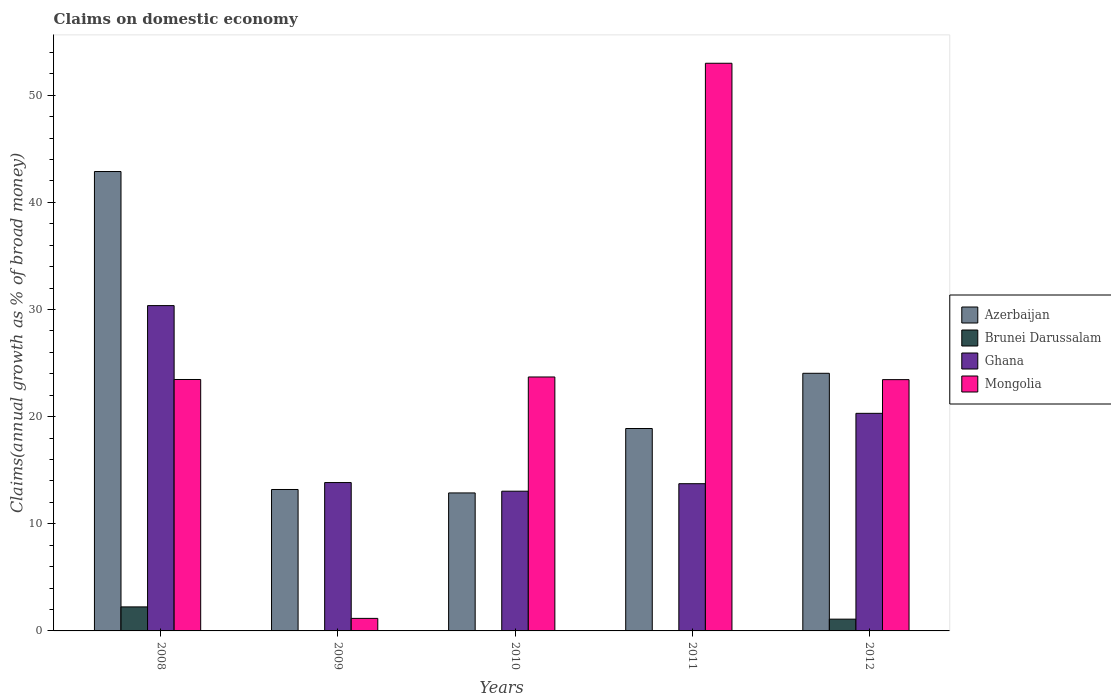How many different coloured bars are there?
Provide a succinct answer. 4. How many bars are there on the 5th tick from the left?
Your response must be concise. 4. What is the percentage of broad money claimed on domestic economy in Azerbaijan in 2008?
Your answer should be very brief. 42.88. Across all years, what is the maximum percentage of broad money claimed on domestic economy in Mongolia?
Your answer should be very brief. 52.99. Across all years, what is the minimum percentage of broad money claimed on domestic economy in Azerbaijan?
Offer a terse response. 12.88. In which year was the percentage of broad money claimed on domestic economy in Ghana maximum?
Offer a very short reply. 2008. What is the total percentage of broad money claimed on domestic economy in Mongolia in the graph?
Keep it short and to the point. 124.78. What is the difference between the percentage of broad money claimed on domestic economy in Mongolia in 2011 and that in 2012?
Give a very brief answer. 29.53. What is the difference between the percentage of broad money claimed on domestic economy in Ghana in 2011 and the percentage of broad money claimed on domestic economy in Azerbaijan in 2010?
Offer a very short reply. 0.86. What is the average percentage of broad money claimed on domestic economy in Brunei Darussalam per year?
Your answer should be very brief. 0.67. In the year 2012, what is the difference between the percentage of broad money claimed on domestic economy in Ghana and percentage of broad money claimed on domestic economy in Brunei Darussalam?
Your response must be concise. 19.21. In how many years, is the percentage of broad money claimed on domestic economy in Azerbaijan greater than 10 %?
Your answer should be compact. 5. What is the ratio of the percentage of broad money claimed on domestic economy in Azerbaijan in 2008 to that in 2011?
Give a very brief answer. 2.27. Is the percentage of broad money claimed on domestic economy in Azerbaijan in 2008 less than that in 2012?
Offer a very short reply. No. What is the difference between the highest and the second highest percentage of broad money claimed on domestic economy in Ghana?
Your answer should be compact. 10.06. What is the difference between the highest and the lowest percentage of broad money claimed on domestic economy in Brunei Darussalam?
Provide a short and direct response. 2.24. Is it the case that in every year, the sum of the percentage of broad money claimed on domestic economy in Ghana and percentage of broad money claimed on domestic economy in Mongolia is greater than the percentage of broad money claimed on domestic economy in Azerbaijan?
Make the answer very short. Yes. Are all the bars in the graph horizontal?
Ensure brevity in your answer.  No. Are the values on the major ticks of Y-axis written in scientific E-notation?
Your answer should be compact. No. Does the graph contain grids?
Provide a short and direct response. No. How many legend labels are there?
Your response must be concise. 4. How are the legend labels stacked?
Your answer should be very brief. Vertical. What is the title of the graph?
Provide a short and direct response. Claims on domestic economy. What is the label or title of the Y-axis?
Your answer should be compact. Claims(annual growth as % of broad money). What is the Claims(annual growth as % of broad money) of Azerbaijan in 2008?
Your answer should be very brief. 42.88. What is the Claims(annual growth as % of broad money) of Brunei Darussalam in 2008?
Ensure brevity in your answer.  2.24. What is the Claims(annual growth as % of broad money) in Ghana in 2008?
Make the answer very short. 30.37. What is the Claims(annual growth as % of broad money) of Mongolia in 2008?
Ensure brevity in your answer.  23.47. What is the Claims(annual growth as % of broad money) in Azerbaijan in 2009?
Keep it short and to the point. 13.2. What is the Claims(annual growth as % of broad money) in Brunei Darussalam in 2009?
Your answer should be compact. 0. What is the Claims(annual growth as % of broad money) of Ghana in 2009?
Provide a succinct answer. 13.85. What is the Claims(annual growth as % of broad money) of Mongolia in 2009?
Give a very brief answer. 1.17. What is the Claims(annual growth as % of broad money) in Azerbaijan in 2010?
Offer a terse response. 12.88. What is the Claims(annual growth as % of broad money) of Brunei Darussalam in 2010?
Give a very brief answer. 0. What is the Claims(annual growth as % of broad money) of Ghana in 2010?
Offer a very short reply. 13.04. What is the Claims(annual growth as % of broad money) of Mongolia in 2010?
Provide a short and direct response. 23.7. What is the Claims(annual growth as % of broad money) of Azerbaijan in 2011?
Provide a succinct answer. 18.89. What is the Claims(annual growth as % of broad money) in Ghana in 2011?
Provide a succinct answer. 13.74. What is the Claims(annual growth as % of broad money) in Mongolia in 2011?
Your answer should be compact. 52.99. What is the Claims(annual growth as % of broad money) in Azerbaijan in 2012?
Your response must be concise. 24.05. What is the Claims(annual growth as % of broad money) of Brunei Darussalam in 2012?
Make the answer very short. 1.1. What is the Claims(annual growth as % of broad money) of Ghana in 2012?
Ensure brevity in your answer.  20.31. What is the Claims(annual growth as % of broad money) in Mongolia in 2012?
Keep it short and to the point. 23.46. Across all years, what is the maximum Claims(annual growth as % of broad money) of Azerbaijan?
Your response must be concise. 42.88. Across all years, what is the maximum Claims(annual growth as % of broad money) in Brunei Darussalam?
Provide a short and direct response. 2.24. Across all years, what is the maximum Claims(annual growth as % of broad money) in Ghana?
Your answer should be very brief. 30.37. Across all years, what is the maximum Claims(annual growth as % of broad money) of Mongolia?
Your answer should be compact. 52.99. Across all years, what is the minimum Claims(annual growth as % of broad money) of Azerbaijan?
Offer a very short reply. 12.88. Across all years, what is the minimum Claims(annual growth as % of broad money) in Ghana?
Your answer should be very brief. 13.04. Across all years, what is the minimum Claims(annual growth as % of broad money) in Mongolia?
Make the answer very short. 1.17. What is the total Claims(annual growth as % of broad money) of Azerbaijan in the graph?
Your response must be concise. 111.9. What is the total Claims(annual growth as % of broad money) in Brunei Darussalam in the graph?
Provide a short and direct response. 3.34. What is the total Claims(annual growth as % of broad money) of Ghana in the graph?
Offer a very short reply. 91.31. What is the total Claims(annual growth as % of broad money) of Mongolia in the graph?
Make the answer very short. 124.78. What is the difference between the Claims(annual growth as % of broad money) of Azerbaijan in 2008 and that in 2009?
Offer a terse response. 29.68. What is the difference between the Claims(annual growth as % of broad money) of Ghana in 2008 and that in 2009?
Your answer should be very brief. 16.52. What is the difference between the Claims(annual growth as % of broad money) of Mongolia in 2008 and that in 2009?
Offer a very short reply. 22.3. What is the difference between the Claims(annual growth as % of broad money) of Azerbaijan in 2008 and that in 2010?
Ensure brevity in your answer.  30. What is the difference between the Claims(annual growth as % of broad money) of Ghana in 2008 and that in 2010?
Provide a succinct answer. 17.32. What is the difference between the Claims(annual growth as % of broad money) of Mongolia in 2008 and that in 2010?
Give a very brief answer. -0.23. What is the difference between the Claims(annual growth as % of broad money) of Azerbaijan in 2008 and that in 2011?
Your response must be concise. 23.99. What is the difference between the Claims(annual growth as % of broad money) in Ghana in 2008 and that in 2011?
Ensure brevity in your answer.  16.62. What is the difference between the Claims(annual growth as % of broad money) in Mongolia in 2008 and that in 2011?
Make the answer very short. -29.52. What is the difference between the Claims(annual growth as % of broad money) of Azerbaijan in 2008 and that in 2012?
Your answer should be compact. 18.83. What is the difference between the Claims(annual growth as % of broad money) of Brunei Darussalam in 2008 and that in 2012?
Your response must be concise. 1.14. What is the difference between the Claims(annual growth as % of broad money) in Ghana in 2008 and that in 2012?
Ensure brevity in your answer.  10.06. What is the difference between the Claims(annual growth as % of broad money) of Mongolia in 2008 and that in 2012?
Offer a very short reply. 0.01. What is the difference between the Claims(annual growth as % of broad money) of Azerbaijan in 2009 and that in 2010?
Your answer should be compact. 0.32. What is the difference between the Claims(annual growth as % of broad money) in Ghana in 2009 and that in 2010?
Provide a short and direct response. 0.81. What is the difference between the Claims(annual growth as % of broad money) in Mongolia in 2009 and that in 2010?
Your answer should be compact. -22.53. What is the difference between the Claims(annual growth as % of broad money) in Azerbaijan in 2009 and that in 2011?
Provide a short and direct response. -5.69. What is the difference between the Claims(annual growth as % of broad money) of Ghana in 2009 and that in 2011?
Provide a short and direct response. 0.11. What is the difference between the Claims(annual growth as % of broad money) of Mongolia in 2009 and that in 2011?
Offer a very short reply. -51.82. What is the difference between the Claims(annual growth as % of broad money) in Azerbaijan in 2009 and that in 2012?
Offer a very short reply. -10.85. What is the difference between the Claims(annual growth as % of broad money) of Ghana in 2009 and that in 2012?
Provide a succinct answer. -6.46. What is the difference between the Claims(annual growth as % of broad money) of Mongolia in 2009 and that in 2012?
Your answer should be compact. -22.28. What is the difference between the Claims(annual growth as % of broad money) of Azerbaijan in 2010 and that in 2011?
Keep it short and to the point. -6.01. What is the difference between the Claims(annual growth as % of broad money) in Ghana in 2010 and that in 2011?
Make the answer very short. -0.7. What is the difference between the Claims(annual growth as % of broad money) of Mongolia in 2010 and that in 2011?
Make the answer very short. -29.28. What is the difference between the Claims(annual growth as % of broad money) of Azerbaijan in 2010 and that in 2012?
Keep it short and to the point. -11.17. What is the difference between the Claims(annual growth as % of broad money) in Ghana in 2010 and that in 2012?
Give a very brief answer. -7.27. What is the difference between the Claims(annual growth as % of broad money) of Mongolia in 2010 and that in 2012?
Keep it short and to the point. 0.25. What is the difference between the Claims(annual growth as % of broad money) in Azerbaijan in 2011 and that in 2012?
Your response must be concise. -5.16. What is the difference between the Claims(annual growth as % of broad money) in Ghana in 2011 and that in 2012?
Your response must be concise. -6.57. What is the difference between the Claims(annual growth as % of broad money) of Mongolia in 2011 and that in 2012?
Offer a very short reply. 29.53. What is the difference between the Claims(annual growth as % of broad money) in Azerbaijan in 2008 and the Claims(annual growth as % of broad money) in Ghana in 2009?
Keep it short and to the point. 29.03. What is the difference between the Claims(annual growth as % of broad money) in Azerbaijan in 2008 and the Claims(annual growth as % of broad money) in Mongolia in 2009?
Your answer should be very brief. 41.71. What is the difference between the Claims(annual growth as % of broad money) of Brunei Darussalam in 2008 and the Claims(annual growth as % of broad money) of Ghana in 2009?
Provide a short and direct response. -11.61. What is the difference between the Claims(annual growth as % of broad money) of Brunei Darussalam in 2008 and the Claims(annual growth as % of broad money) of Mongolia in 2009?
Your response must be concise. 1.07. What is the difference between the Claims(annual growth as % of broad money) in Ghana in 2008 and the Claims(annual growth as % of broad money) in Mongolia in 2009?
Keep it short and to the point. 29.2. What is the difference between the Claims(annual growth as % of broad money) in Azerbaijan in 2008 and the Claims(annual growth as % of broad money) in Ghana in 2010?
Offer a very short reply. 29.84. What is the difference between the Claims(annual growth as % of broad money) in Azerbaijan in 2008 and the Claims(annual growth as % of broad money) in Mongolia in 2010?
Your answer should be very brief. 19.18. What is the difference between the Claims(annual growth as % of broad money) in Brunei Darussalam in 2008 and the Claims(annual growth as % of broad money) in Ghana in 2010?
Keep it short and to the point. -10.8. What is the difference between the Claims(annual growth as % of broad money) in Brunei Darussalam in 2008 and the Claims(annual growth as % of broad money) in Mongolia in 2010?
Offer a terse response. -21.46. What is the difference between the Claims(annual growth as % of broad money) of Ghana in 2008 and the Claims(annual growth as % of broad money) of Mongolia in 2010?
Make the answer very short. 6.66. What is the difference between the Claims(annual growth as % of broad money) in Azerbaijan in 2008 and the Claims(annual growth as % of broad money) in Ghana in 2011?
Your answer should be very brief. 29.14. What is the difference between the Claims(annual growth as % of broad money) of Azerbaijan in 2008 and the Claims(annual growth as % of broad money) of Mongolia in 2011?
Make the answer very short. -10.1. What is the difference between the Claims(annual growth as % of broad money) in Brunei Darussalam in 2008 and the Claims(annual growth as % of broad money) in Ghana in 2011?
Make the answer very short. -11.5. What is the difference between the Claims(annual growth as % of broad money) in Brunei Darussalam in 2008 and the Claims(annual growth as % of broad money) in Mongolia in 2011?
Offer a very short reply. -50.74. What is the difference between the Claims(annual growth as % of broad money) in Ghana in 2008 and the Claims(annual growth as % of broad money) in Mongolia in 2011?
Make the answer very short. -22.62. What is the difference between the Claims(annual growth as % of broad money) of Azerbaijan in 2008 and the Claims(annual growth as % of broad money) of Brunei Darussalam in 2012?
Your answer should be compact. 41.78. What is the difference between the Claims(annual growth as % of broad money) in Azerbaijan in 2008 and the Claims(annual growth as % of broad money) in Ghana in 2012?
Give a very brief answer. 22.57. What is the difference between the Claims(annual growth as % of broad money) of Azerbaijan in 2008 and the Claims(annual growth as % of broad money) of Mongolia in 2012?
Ensure brevity in your answer.  19.43. What is the difference between the Claims(annual growth as % of broad money) of Brunei Darussalam in 2008 and the Claims(annual growth as % of broad money) of Ghana in 2012?
Your answer should be very brief. -18.07. What is the difference between the Claims(annual growth as % of broad money) in Brunei Darussalam in 2008 and the Claims(annual growth as % of broad money) in Mongolia in 2012?
Your answer should be compact. -21.21. What is the difference between the Claims(annual growth as % of broad money) of Ghana in 2008 and the Claims(annual growth as % of broad money) of Mongolia in 2012?
Ensure brevity in your answer.  6.91. What is the difference between the Claims(annual growth as % of broad money) in Azerbaijan in 2009 and the Claims(annual growth as % of broad money) in Ghana in 2010?
Provide a succinct answer. 0.16. What is the difference between the Claims(annual growth as % of broad money) of Azerbaijan in 2009 and the Claims(annual growth as % of broad money) of Mongolia in 2010?
Provide a succinct answer. -10.5. What is the difference between the Claims(annual growth as % of broad money) of Ghana in 2009 and the Claims(annual growth as % of broad money) of Mongolia in 2010?
Make the answer very short. -9.85. What is the difference between the Claims(annual growth as % of broad money) of Azerbaijan in 2009 and the Claims(annual growth as % of broad money) of Ghana in 2011?
Provide a succinct answer. -0.54. What is the difference between the Claims(annual growth as % of broad money) in Azerbaijan in 2009 and the Claims(annual growth as % of broad money) in Mongolia in 2011?
Your answer should be very brief. -39.79. What is the difference between the Claims(annual growth as % of broad money) in Ghana in 2009 and the Claims(annual growth as % of broad money) in Mongolia in 2011?
Provide a succinct answer. -39.14. What is the difference between the Claims(annual growth as % of broad money) in Azerbaijan in 2009 and the Claims(annual growth as % of broad money) in Brunei Darussalam in 2012?
Keep it short and to the point. 12.1. What is the difference between the Claims(annual growth as % of broad money) in Azerbaijan in 2009 and the Claims(annual growth as % of broad money) in Ghana in 2012?
Your response must be concise. -7.11. What is the difference between the Claims(annual growth as % of broad money) in Azerbaijan in 2009 and the Claims(annual growth as % of broad money) in Mongolia in 2012?
Your response must be concise. -10.25. What is the difference between the Claims(annual growth as % of broad money) in Ghana in 2009 and the Claims(annual growth as % of broad money) in Mongolia in 2012?
Your answer should be very brief. -9.61. What is the difference between the Claims(annual growth as % of broad money) of Azerbaijan in 2010 and the Claims(annual growth as % of broad money) of Ghana in 2011?
Offer a terse response. -0.86. What is the difference between the Claims(annual growth as % of broad money) in Azerbaijan in 2010 and the Claims(annual growth as % of broad money) in Mongolia in 2011?
Give a very brief answer. -40.11. What is the difference between the Claims(annual growth as % of broad money) in Ghana in 2010 and the Claims(annual growth as % of broad money) in Mongolia in 2011?
Ensure brevity in your answer.  -39.94. What is the difference between the Claims(annual growth as % of broad money) of Azerbaijan in 2010 and the Claims(annual growth as % of broad money) of Brunei Darussalam in 2012?
Keep it short and to the point. 11.78. What is the difference between the Claims(annual growth as % of broad money) of Azerbaijan in 2010 and the Claims(annual growth as % of broad money) of Ghana in 2012?
Provide a short and direct response. -7.43. What is the difference between the Claims(annual growth as % of broad money) of Azerbaijan in 2010 and the Claims(annual growth as % of broad money) of Mongolia in 2012?
Give a very brief answer. -10.58. What is the difference between the Claims(annual growth as % of broad money) in Ghana in 2010 and the Claims(annual growth as % of broad money) in Mongolia in 2012?
Your response must be concise. -10.41. What is the difference between the Claims(annual growth as % of broad money) of Azerbaijan in 2011 and the Claims(annual growth as % of broad money) of Brunei Darussalam in 2012?
Your answer should be compact. 17.79. What is the difference between the Claims(annual growth as % of broad money) in Azerbaijan in 2011 and the Claims(annual growth as % of broad money) in Ghana in 2012?
Your answer should be very brief. -1.42. What is the difference between the Claims(annual growth as % of broad money) in Azerbaijan in 2011 and the Claims(annual growth as % of broad money) in Mongolia in 2012?
Give a very brief answer. -4.56. What is the difference between the Claims(annual growth as % of broad money) in Ghana in 2011 and the Claims(annual growth as % of broad money) in Mongolia in 2012?
Offer a terse response. -9.71. What is the average Claims(annual growth as % of broad money) in Azerbaijan per year?
Ensure brevity in your answer.  22.38. What is the average Claims(annual growth as % of broad money) in Brunei Darussalam per year?
Ensure brevity in your answer.  0.67. What is the average Claims(annual growth as % of broad money) of Ghana per year?
Your response must be concise. 18.26. What is the average Claims(annual growth as % of broad money) in Mongolia per year?
Your answer should be very brief. 24.96. In the year 2008, what is the difference between the Claims(annual growth as % of broad money) in Azerbaijan and Claims(annual growth as % of broad money) in Brunei Darussalam?
Keep it short and to the point. 40.64. In the year 2008, what is the difference between the Claims(annual growth as % of broad money) of Azerbaijan and Claims(annual growth as % of broad money) of Ghana?
Your response must be concise. 12.52. In the year 2008, what is the difference between the Claims(annual growth as % of broad money) of Azerbaijan and Claims(annual growth as % of broad money) of Mongolia?
Your response must be concise. 19.41. In the year 2008, what is the difference between the Claims(annual growth as % of broad money) in Brunei Darussalam and Claims(annual growth as % of broad money) in Ghana?
Your answer should be compact. -28.12. In the year 2008, what is the difference between the Claims(annual growth as % of broad money) in Brunei Darussalam and Claims(annual growth as % of broad money) in Mongolia?
Make the answer very short. -21.23. In the year 2008, what is the difference between the Claims(annual growth as % of broad money) in Ghana and Claims(annual growth as % of broad money) in Mongolia?
Your answer should be compact. 6.9. In the year 2009, what is the difference between the Claims(annual growth as % of broad money) of Azerbaijan and Claims(annual growth as % of broad money) of Ghana?
Your answer should be very brief. -0.65. In the year 2009, what is the difference between the Claims(annual growth as % of broad money) in Azerbaijan and Claims(annual growth as % of broad money) in Mongolia?
Ensure brevity in your answer.  12.03. In the year 2009, what is the difference between the Claims(annual growth as % of broad money) in Ghana and Claims(annual growth as % of broad money) in Mongolia?
Your response must be concise. 12.68. In the year 2010, what is the difference between the Claims(annual growth as % of broad money) in Azerbaijan and Claims(annual growth as % of broad money) in Ghana?
Offer a terse response. -0.16. In the year 2010, what is the difference between the Claims(annual growth as % of broad money) of Azerbaijan and Claims(annual growth as % of broad money) of Mongolia?
Ensure brevity in your answer.  -10.82. In the year 2010, what is the difference between the Claims(annual growth as % of broad money) in Ghana and Claims(annual growth as % of broad money) in Mongolia?
Your response must be concise. -10.66. In the year 2011, what is the difference between the Claims(annual growth as % of broad money) of Azerbaijan and Claims(annual growth as % of broad money) of Ghana?
Your answer should be compact. 5.15. In the year 2011, what is the difference between the Claims(annual growth as % of broad money) of Azerbaijan and Claims(annual growth as % of broad money) of Mongolia?
Ensure brevity in your answer.  -34.09. In the year 2011, what is the difference between the Claims(annual growth as % of broad money) of Ghana and Claims(annual growth as % of broad money) of Mongolia?
Offer a terse response. -39.24. In the year 2012, what is the difference between the Claims(annual growth as % of broad money) of Azerbaijan and Claims(annual growth as % of broad money) of Brunei Darussalam?
Offer a terse response. 22.95. In the year 2012, what is the difference between the Claims(annual growth as % of broad money) in Azerbaijan and Claims(annual growth as % of broad money) in Ghana?
Provide a short and direct response. 3.74. In the year 2012, what is the difference between the Claims(annual growth as % of broad money) of Azerbaijan and Claims(annual growth as % of broad money) of Mongolia?
Ensure brevity in your answer.  0.59. In the year 2012, what is the difference between the Claims(annual growth as % of broad money) in Brunei Darussalam and Claims(annual growth as % of broad money) in Ghana?
Make the answer very short. -19.21. In the year 2012, what is the difference between the Claims(annual growth as % of broad money) in Brunei Darussalam and Claims(annual growth as % of broad money) in Mongolia?
Make the answer very short. -22.36. In the year 2012, what is the difference between the Claims(annual growth as % of broad money) in Ghana and Claims(annual growth as % of broad money) in Mongolia?
Your answer should be very brief. -3.15. What is the ratio of the Claims(annual growth as % of broad money) of Azerbaijan in 2008 to that in 2009?
Provide a short and direct response. 3.25. What is the ratio of the Claims(annual growth as % of broad money) of Ghana in 2008 to that in 2009?
Ensure brevity in your answer.  2.19. What is the ratio of the Claims(annual growth as % of broad money) of Mongolia in 2008 to that in 2009?
Make the answer very short. 20.05. What is the ratio of the Claims(annual growth as % of broad money) in Azerbaijan in 2008 to that in 2010?
Your answer should be compact. 3.33. What is the ratio of the Claims(annual growth as % of broad money) of Ghana in 2008 to that in 2010?
Offer a terse response. 2.33. What is the ratio of the Claims(annual growth as % of broad money) of Mongolia in 2008 to that in 2010?
Your answer should be compact. 0.99. What is the ratio of the Claims(annual growth as % of broad money) of Azerbaijan in 2008 to that in 2011?
Keep it short and to the point. 2.27. What is the ratio of the Claims(annual growth as % of broad money) of Ghana in 2008 to that in 2011?
Provide a succinct answer. 2.21. What is the ratio of the Claims(annual growth as % of broad money) in Mongolia in 2008 to that in 2011?
Offer a terse response. 0.44. What is the ratio of the Claims(annual growth as % of broad money) in Azerbaijan in 2008 to that in 2012?
Give a very brief answer. 1.78. What is the ratio of the Claims(annual growth as % of broad money) of Brunei Darussalam in 2008 to that in 2012?
Provide a succinct answer. 2.04. What is the ratio of the Claims(annual growth as % of broad money) of Ghana in 2008 to that in 2012?
Provide a succinct answer. 1.5. What is the ratio of the Claims(annual growth as % of broad money) in Azerbaijan in 2009 to that in 2010?
Keep it short and to the point. 1.02. What is the ratio of the Claims(annual growth as % of broad money) in Ghana in 2009 to that in 2010?
Your answer should be compact. 1.06. What is the ratio of the Claims(annual growth as % of broad money) in Mongolia in 2009 to that in 2010?
Your answer should be compact. 0.05. What is the ratio of the Claims(annual growth as % of broad money) of Azerbaijan in 2009 to that in 2011?
Offer a very short reply. 0.7. What is the ratio of the Claims(annual growth as % of broad money) of Ghana in 2009 to that in 2011?
Your answer should be very brief. 1.01. What is the ratio of the Claims(annual growth as % of broad money) of Mongolia in 2009 to that in 2011?
Your answer should be compact. 0.02. What is the ratio of the Claims(annual growth as % of broad money) of Azerbaijan in 2009 to that in 2012?
Keep it short and to the point. 0.55. What is the ratio of the Claims(annual growth as % of broad money) in Ghana in 2009 to that in 2012?
Make the answer very short. 0.68. What is the ratio of the Claims(annual growth as % of broad money) in Mongolia in 2009 to that in 2012?
Offer a terse response. 0.05. What is the ratio of the Claims(annual growth as % of broad money) in Azerbaijan in 2010 to that in 2011?
Ensure brevity in your answer.  0.68. What is the ratio of the Claims(annual growth as % of broad money) in Ghana in 2010 to that in 2011?
Your answer should be very brief. 0.95. What is the ratio of the Claims(annual growth as % of broad money) of Mongolia in 2010 to that in 2011?
Your response must be concise. 0.45. What is the ratio of the Claims(annual growth as % of broad money) of Azerbaijan in 2010 to that in 2012?
Provide a short and direct response. 0.54. What is the ratio of the Claims(annual growth as % of broad money) of Ghana in 2010 to that in 2012?
Your answer should be very brief. 0.64. What is the ratio of the Claims(annual growth as % of broad money) of Mongolia in 2010 to that in 2012?
Make the answer very short. 1.01. What is the ratio of the Claims(annual growth as % of broad money) of Azerbaijan in 2011 to that in 2012?
Give a very brief answer. 0.79. What is the ratio of the Claims(annual growth as % of broad money) of Ghana in 2011 to that in 2012?
Your response must be concise. 0.68. What is the ratio of the Claims(annual growth as % of broad money) of Mongolia in 2011 to that in 2012?
Keep it short and to the point. 2.26. What is the difference between the highest and the second highest Claims(annual growth as % of broad money) of Azerbaijan?
Keep it short and to the point. 18.83. What is the difference between the highest and the second highest Claims(annual growth as % of broad money) of Ghana?
Offer a terse response. 10.06. What is the difference between the highest and the second highest Claims(annual growth as % of broad money) in Mongolia?
Offer a terse response. 29.28. What is the difference between the highest and the lowest Claims(annual growth as % of broad money) of Azerbaijan?
Provide a short and direct response. 30. What is the difference between the highest and the lowest Claims(annual growth as % of broad money) of Brunei Darussalam?
Provide a succinct answer. 2.24. What is the difference between the highest and the lowest Claims(annual growth as % of broad money) in Ghana?
Make the answer very short. 17.32. What is the difference between the highest and the lowest Claims(annual growth as % of broad money) of Mongolia?
Offer a very short reply. 51.82. 